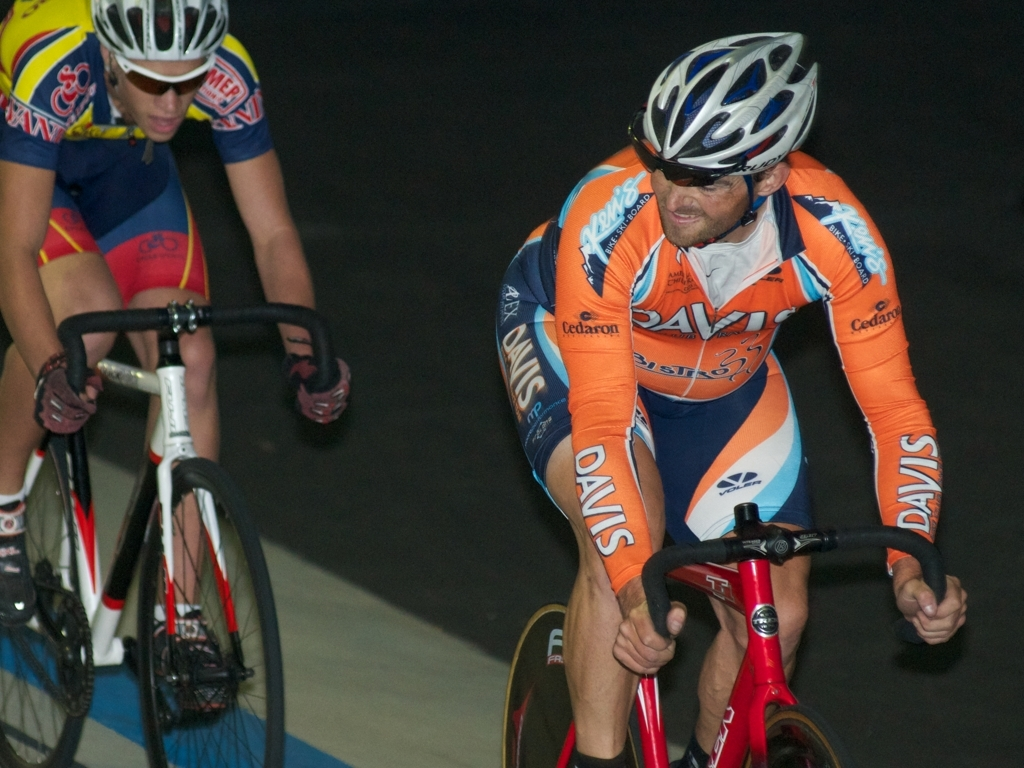Can you describe the setting of this competition? The image captures an indoor velodrome, a special arena for track cycling. The curved, banked track demonstrates the design tailored for high-speed cycling, while the subdued lighting focuses on the cyclists, implying that the event is taking place during an active race where competitors are striving for speed and precision. What can you tell about the cyclists' expressions and body language? The cyclists exhibit a combination of determination and focus. Their eyes are locked ahead, indicating concentration on their path and strategy. The posture and tense muscles underline the physical demand of the race, showcasing the effort and endurance required in competitive cycling. 